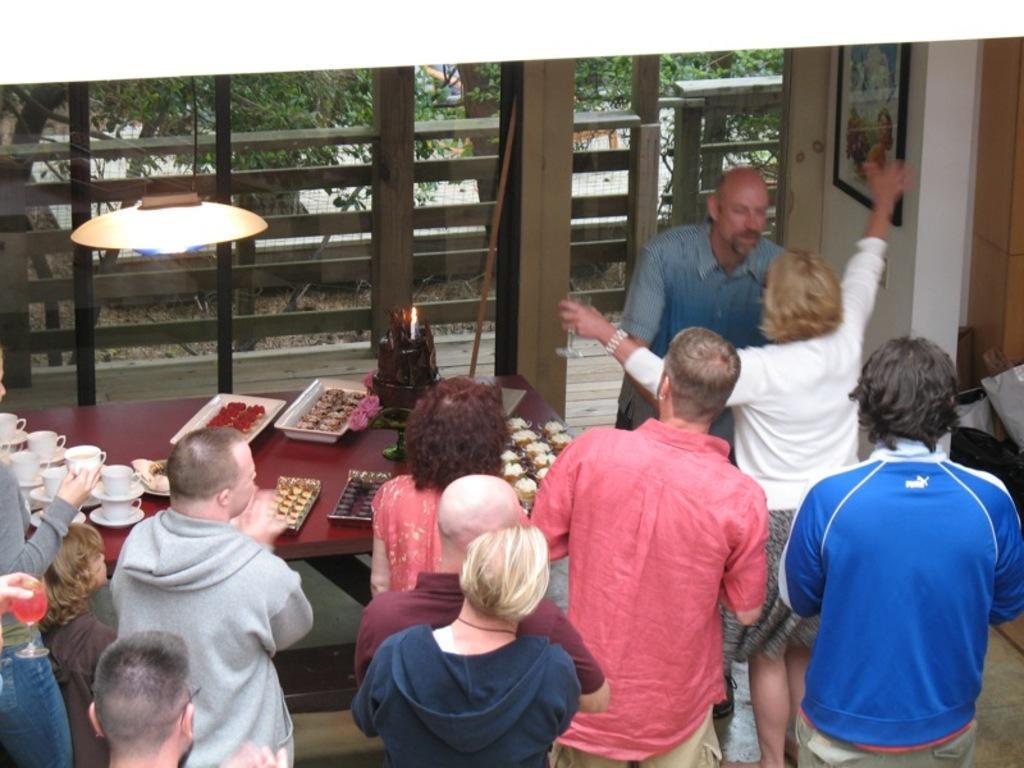Please provide a concise description of this image. In the foreground of this image, there are persons standing on the floor and also a man and a woman facing to each other. Beside them, there is a table on which, cups, saucers, trays with food, cakes are on it. On the top, there is a light, glass wall, a frame on the wall is on the right side and behind the glass there is a railing and few trees. 